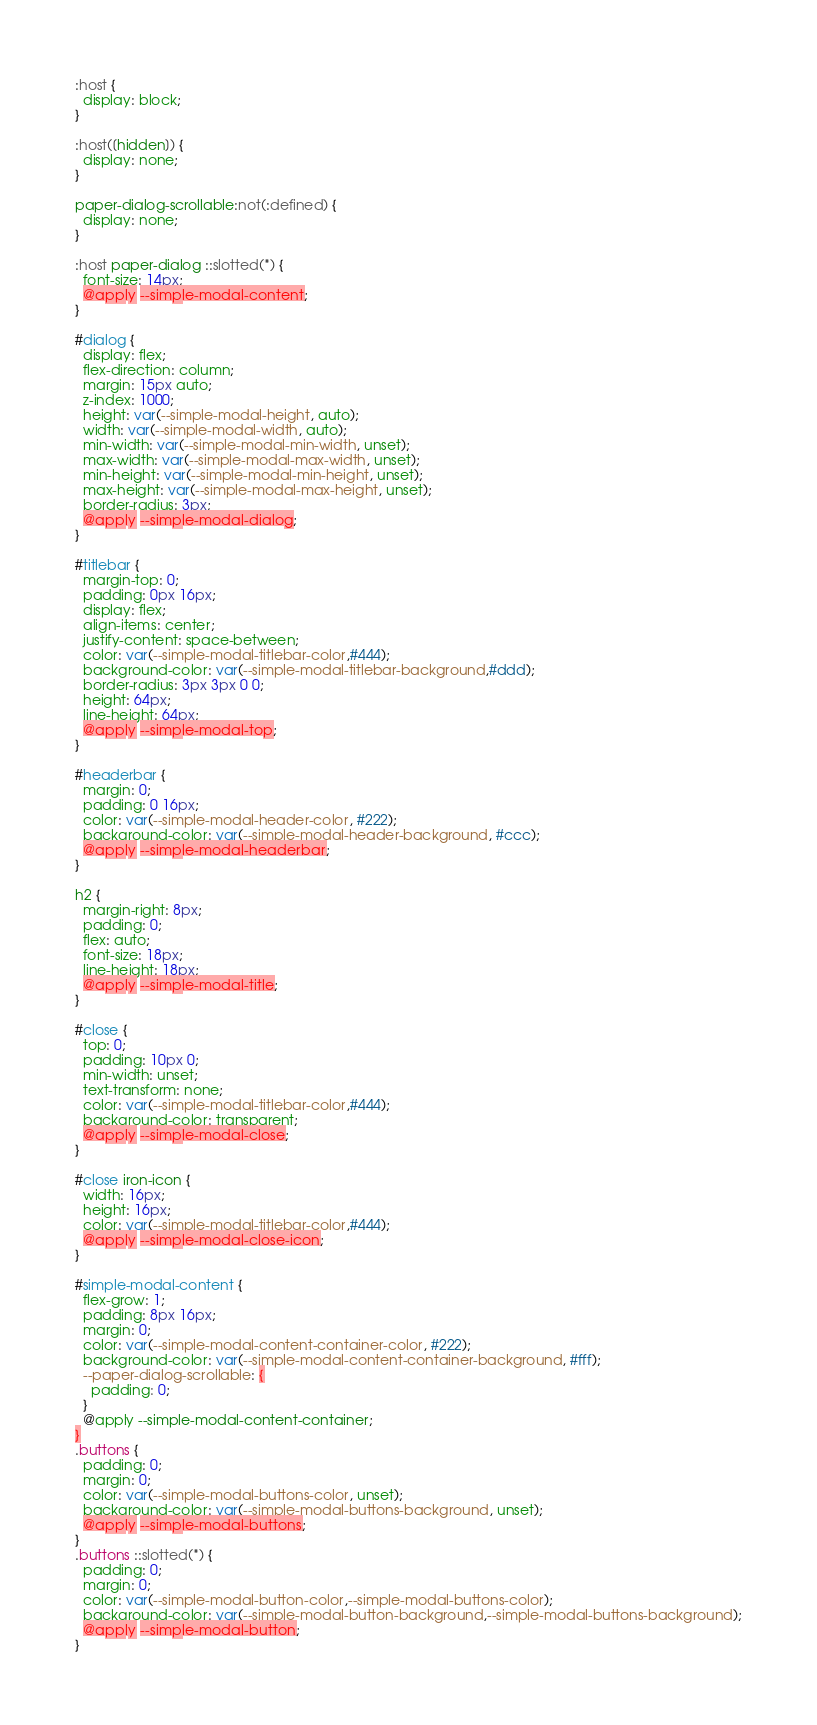<code> <loc_0><loc_0><loc_500><loc_500><_CSS_>:host {
  display: block;
}

:host([hidden]) {
  display: none;
}

paper-dialog-scrollable:not(:defined) {
  display: none;
}

:host paper-dialog ::slotted(*) {
  font-size: 14px;
  @apply --simple-modal-content;
}

#dialog {
  display: flex;
  flex-direction: column;
  margin: 15px auto;
  z-index: 1000;
  height: var(--simple-modal-height, auto);
  width: var(--simple-modal-width, auto);
  min-width: var(--simple-modal-min-width, unset);
  max-width: var(--simple-modal-max-width, unset);
  min-height: var(--simple-modal-min-height, unset);
  max-height: var(--simple-modal-max-height, unset);
  border-radius: 3px;
  @apply --simple-modal-dialog;
}

#titlebar {
  margin-top: 0;
  padding: 0px 16px;
  display: flex;
  align-items: center;
  justify-content: space-between;
  color: var(--simple-modal-titlebar-color,#444);
  background-color: var(--simple-modal-titlebar-background,#ddd);
  border-radius: 3px 3px 0 0;
  height: 64px;
  line-height: 64px;
  @apply --simple-modal-top;
}

#headerbar {
  margin: 0;
  padding: 0 16px;
  color: var(--simple-modal-header-color, #222);
  background-color: var(--simple-modal-header-background, #ccc);
  @apply --simple-modal-headerbar;
}

h2 {
  margin-right: 8px;
  padding: 0;
  flex: auto;
  font-size: 18px;
  line-height: 18px;
  @apply --simple-modal-title;
}

#close {
  top: 0;
  padding: 10px 0;
  min-width: unset;
  text-transform: none;
  color: var(--simple-modal-titlebar-color,#444);
  background-color: transparent;
  @apply --simple-modal-close;
}

#close iron-icon {
  width: 16px;
  height: 16px;
  color: var(--simple-modal-titlebar-color,#444);
  @apply --simple-modal-close-icon;
}

#simple-modal-content {
  flex-grow: 1;
  padding: 8px 16px;
  margin: 0;
  color: var(--simple-modal-content-container-color, #222);
  background-color: var(--simple-modal-content-container-background, #fff);
  --paper-dialog-scrollable: {
    padding: 0;
  }
  @apply --simple-modal-content-container;
}
.buttons {
  padding: 0;
  margin: 0;
  color: var(--simple-modal-buttons-color, unset);
  background-color: var(--simple-modal-buttons-background, unset);
  @apply --simple-modal-buttons;
}
.buttons ::slotted(*) {
  padding: 0;
  margin: 0;
  color: var(--simple-modal-button-color,--simple-modal-buttons-color);
  background-color: var(--simple-modal-button-background,--simple-modal-buttons-background);
  @apply --simple-modal-button;
}</code> 